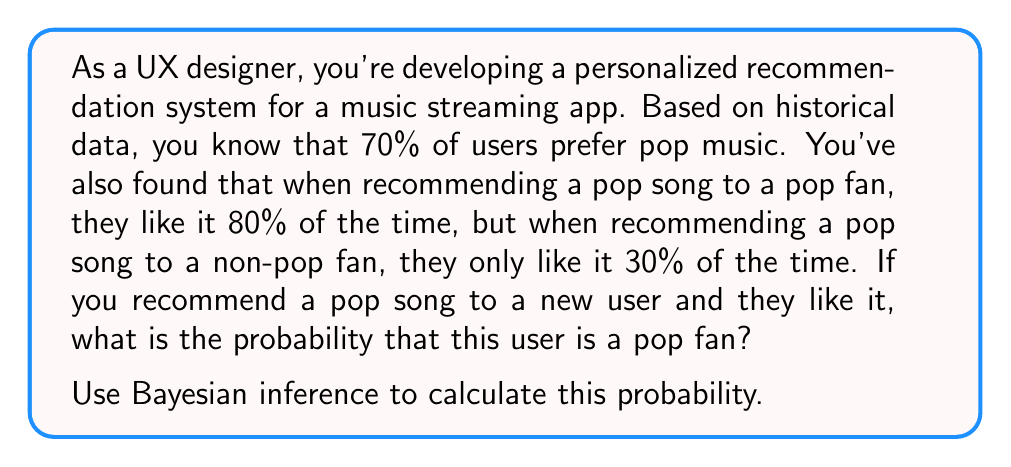Help me with this question. Let's approach this step-by-step using Bayes' theorem:

1) Define our events:
   A: The user is a pop fan
   B: The user likes the recommended pop song

2) Given probabilities:
   P(A) = 0.7 (prior probability of being a pop fan)
   P(B|A) = 0.8 (likelihood of liking a pop song given they're a pop fan)
   P(B|not A) = 0.3 (likelihood of liking a pop song given they're not a pop fan)

3) Bayes' theorem states:

   $$P(A|B) = \frac{P(B|A) \cdot P(A)}{P(B)}$$

4) We need to calculate P(B) using the law of total probability:

   $$P(B) = P(B|A) \cdot P(A) + P(B|not A) \cdot P(not A)$$
   $$P(B) = 0.8 \cdot 0.7 + 0.3 \cdot 0.3 = 0.56 + 0.09 = 0.65$$

5) Now we can apply Bayes' theorem:

   $$P(A|B) = \frac{0.8 \cdot 0.7}{0.65} = \frac{0.56}{0.65} \approx 0.8615$$

6) Convert to a percentage:

   0.8615 * 100% ≈ 86.15%

Therefore, if a new user likes the recommended pop song, there's approximately an 86.15% chance they are a pop fan.
Answer: 86.15% 